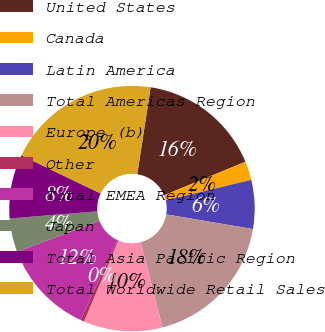<chart> <loc_0><loc_0><loc_500><loc_500><pie_chart><fcel>United States<fcel>Canada<fcel>Latin America<fcel>Total Americas Region<fcel>Europe (b)<fcel>Other<fcel>Total EMEA Region<fcel>Japan<fcel>Total Asia Pacific Region<fcel>Total Worldwide Retail Sales<nl><fcel>16.34%<fcel>2.47%<fcel>6.43%<fcel>18.32%<fcel>10.4%<fcel>0.49%<fcel>12.38%<fcel>4.45%<fcel>8.42%<fcel>20.3%<nl></chart> 